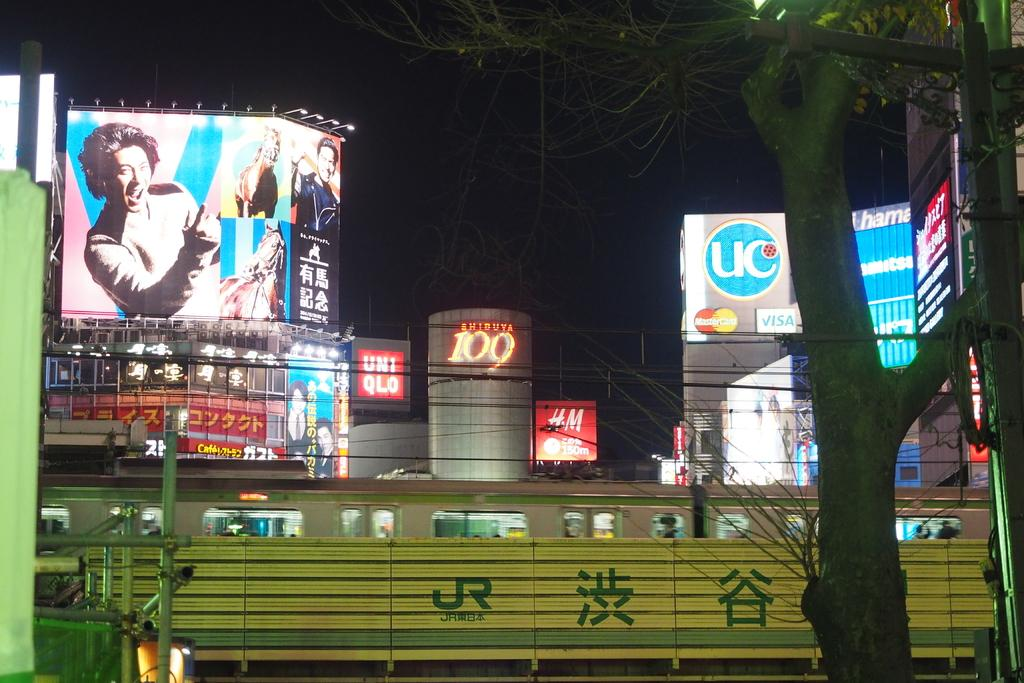Where was the image taken? The image was clicked outside. What can be seen in the middle of the image? There are buildings in the middle of the image. What type of vegetation is on the right side of the image? There is a tree on the right side of the image. What is visible on the left side of the image? There are lights on the left side of the image. What type of fruit is the fireman holding in the image? There is no fireman or fruit present in the image. Can you describe the pear that is hanging from the tree in the image? There is no pear or tree present in the image; it only features buildings, lights, and a tree. 